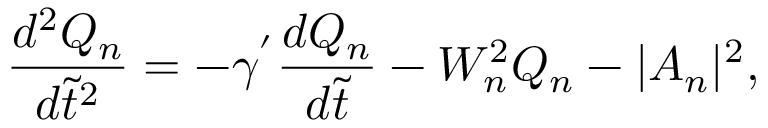Convert formula to latex. <formula><loc_0><loc_0><loc_500><loc_500>\frac { d ^ { 2 } Q _ { n } } { d \tilde { t } ^ { 2 } } = - \gamma ^ { ^ { \prime } } \frac { d Q _ { n } } { d \tilde { t } } - W _ { n } ^ { 2 } Q _ { n } - | A _ { n } | ^ { 2 } ,</formula> 